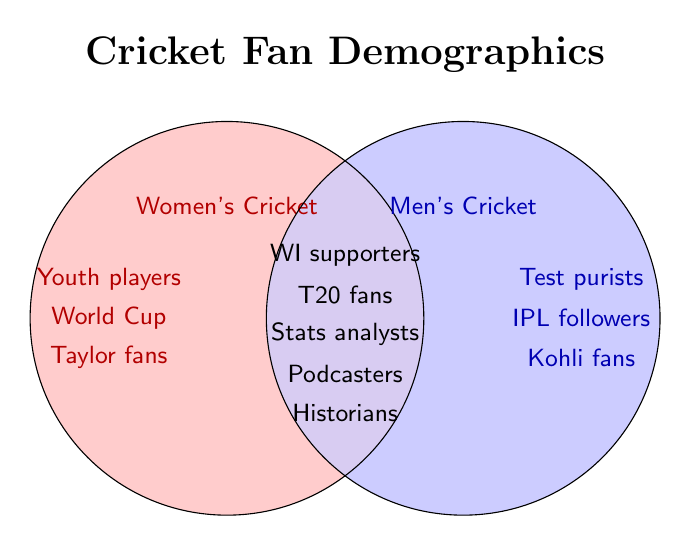Which group is labeled with "Women's Cricket"? The left circle is labeled with "Women's Cricket" because it contains categories like "Youth players," "Taylor fans," and "World Cup viewers," which are not found in the right circle labeled with "Men's Cricket."
Answer: The left circle Which categories are shared by both Women's Cricket and Men's Cricket? Shared categories are placed in the intersecting area of the two circles. These include "WI supporters," "T20 fans," "Stats analysts," "Podcasters," and "Historians."
Answer: WI supporters, T20 fans, Stats analysts, Podcasters, Historians How many categories are unique to Women's Cricket? Count the categories listed only within the "Women's Cricket" circle excluding the intersecting area. These categories are "Youth players," "Taylor fans," and "World Cup viewers."
Answer: 3 Which fan group follows Virat Kohli? The "Kohli fans" category is placed in the "Men's Cricket" circle, indicating that Virat Kohli followers are part of the Men's Cricket fan group.
Answer: Men's Cricket Which single category is unique to Men's Cricket and not present in Women's Cricket or the shared area? "IPL followers" are placed only within the "Men's Cricket" circle without any overlap with the "Women's Cricket" circle or the shared area.
Answer: IPL followers Which categories are exclusively located in the "Women's Cricket" circle but not in the intersection? The categories "Youth players," "Taylor fans," and "World Cup viewers" appear only in the "Women's Cricket" section of the Venn diagram.
Answer: Youth players, Taylor fans, World Cup viewers How many categories are in the intersection of both circles? Count the categories located in the intersecting part of the Venn diagram. The intersection includes "WI supporters," "T20 fans," "Stats analysts," "Podcasters," and "Historians," totaling 5.
Answer: 5 